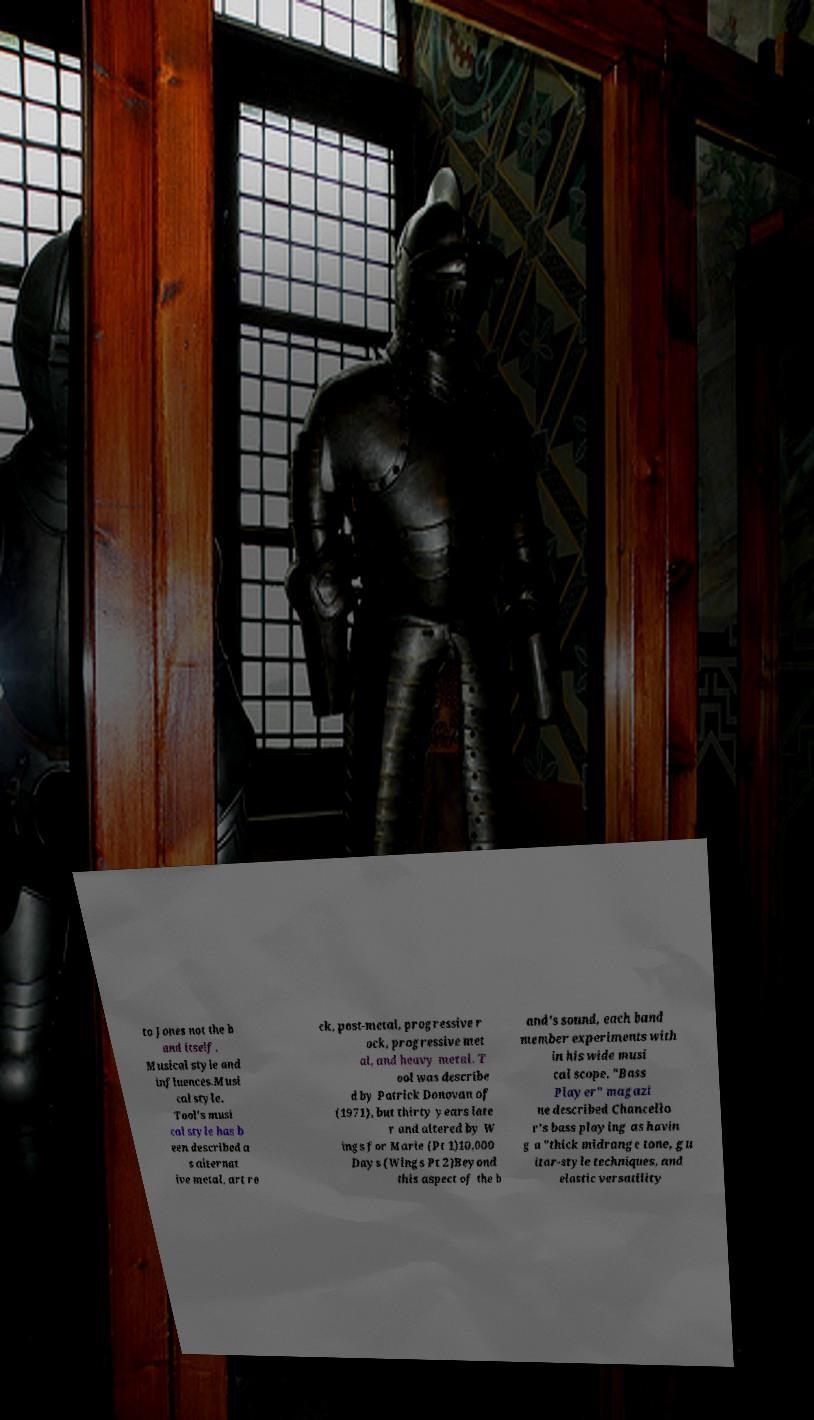Could you assist in decoding the text presented in this image and type it out clearly? to Jones not the b and itself. Musical style and influences.Musi cal style. Tool's musi cal style has b een described a s alternat ive metal, art ro ck, post-metal, progressive r ock, progressive met al, and heavy metal. T ool was describe d by Patrick Donovan of (1971), but thirty years late r and altered by W ings for Marie (Pt 1)10,000 Days (Wings Pt 2)Beyond this aspect of the b and's sound, each band member experiments with in his wide musi cal scope. "Bass Player" magazi ne described Chancello r's bass playing as havin g a "thick midrange tone, gu itar-style techniques, and elastic versatility 